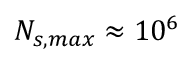Convert formula to latex. <formula><loc_0><loc_0><loc_500><loc_500>N _ { s , \max } \approx 1 0 ^ { 6 }</formula> 